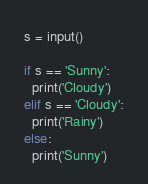Convert code to text. <code><loc_0><loc_0><loc_500><loc_500><_Python_>s = input()

if s == 'Sunny':
  print('Cloudy')
elif s == 'Cloudy':
  print('Rainy')
else:
  print('Sunny')</code> 